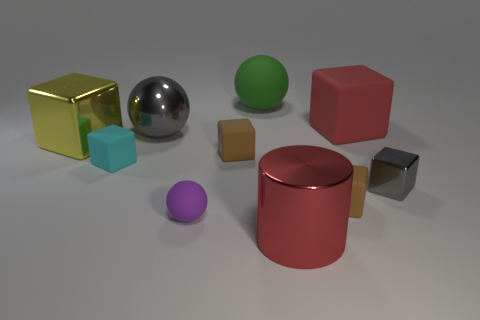Subtract all purple cylinders. How many brown cubes are left? 2 Subtract all gray metallic cubes. How many cubes are left? 5 Subtract all gray cubes. How many cubes are left? 5 Subtract 3 cubes. How many cubes are left? 3 Subtract all purple blocks. Subtract all purple cylinders. How many blocks are left? 6 Subtract all cubes. How many objects are left? 4 Add 5 gray blocks. How many gray blocks are left? 6 Add 10 gray cylinders. How many gray cylinders exist? 10 Subtract 1 red cylinders. How many objects are left? 9 Subtract all small blocks. Subtract all big matte balls. How many objects are left? 5 